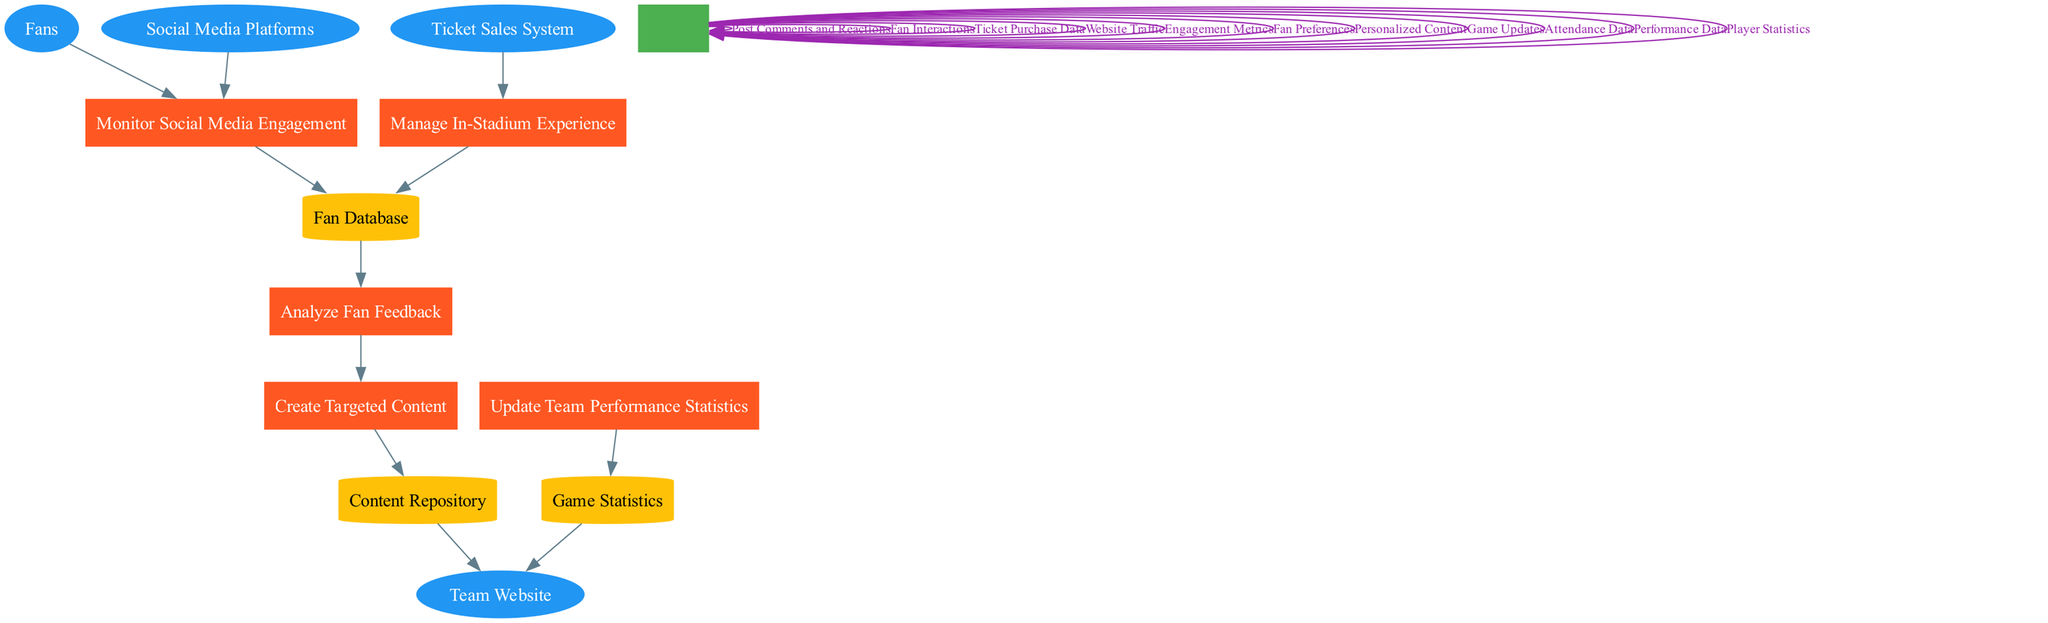What are the external entities in the diagram? The external entities are the main sources interacting with the system in the diagram. Reviewing the diagram, the external entities listed are "Fans," "Social Media Platforms," "Ticket Sales System," and "Team Website."
Answer: Fans, Social Media Platforms, Ticket Sales System, Team Website How many processes are represented in the diagram? Counting the number of rectangle nodes labeled as processes reveals five distinct processes: "Monitor Social Media Engagement," "Analyze Fan Feedback," "Create Targeted Content," "Manage In-Stadium Experience," and "Update Team Performance Statistics."
Answer: 5 What type of data flows into the "Analyze Fan Feedback" process? By examining the connections leading into the "Analyze Fan Feedback" process, it is clear that it receives input from the "Fan Database," which contains the data gathered from monitoring fan engagement and feedback.
Answer: Fan Database Which entity initiates the "Monitor Social Media Engagement" process? Observing the connections leading to the "Monitor Social Media Engagement" process, it can be determined that both "Fans" and "Social Media Platforms" initiate engagement with the team's social media.
Answer: Fans, Social Media Platforms What type of data is generated by the "Manage In-Stadium Experience" process? The process "Manage In-Stadium Experience" connects to the "Fan Database," where information about the fan interactions during the game is stored, highlighting the types of data generated, which include attendance statistics and preferences for in-stadium services.
Answer: Attendance Data, Fan Preferences What data flow comes from the "Content Repository"? Tracing the data flow from the "Content Repository," we see that it supplies "Personalized Content" to the "Team Website," indicating the kind of data leaving this process.
Answer: Personalized Content Which process updates the "Game Statistics"? Reviewing the diagram, it's evident that the "Update Team Performance Statistics" process directly sends updated information to the "Game Statistics" data store, indicating the linkage between performance updates and game statistics.
Answer: Update Team Performance Statistics What is the purpose of the "Create Targeted Content" process? The "Create Targeted Content" process aims to utilize feedback gathered from fans to tailor content that meets their interests, improving engagement and ensuring the content resonates with the audience.
Answer: To tailor content for fan engagement 